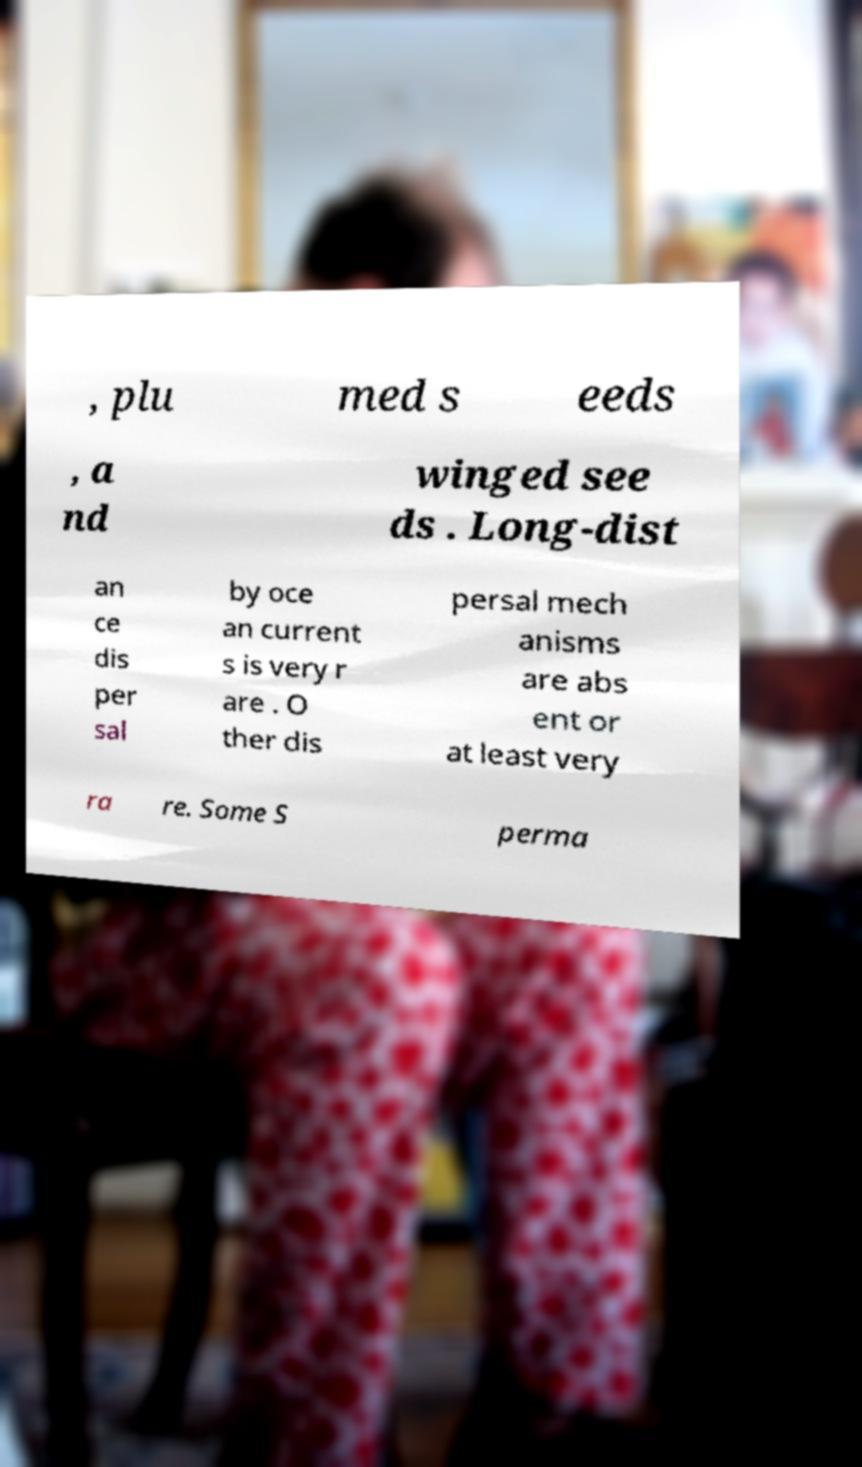Could you assist in decoding the text presented in this image and type it out clearly? , plu med s eeds , a nd winged see ds . Long-dist an ce dis per sal by oce an current s is very r are . O ther dis persal mech anisms are abs ent or at least very ra re. Some S perma 